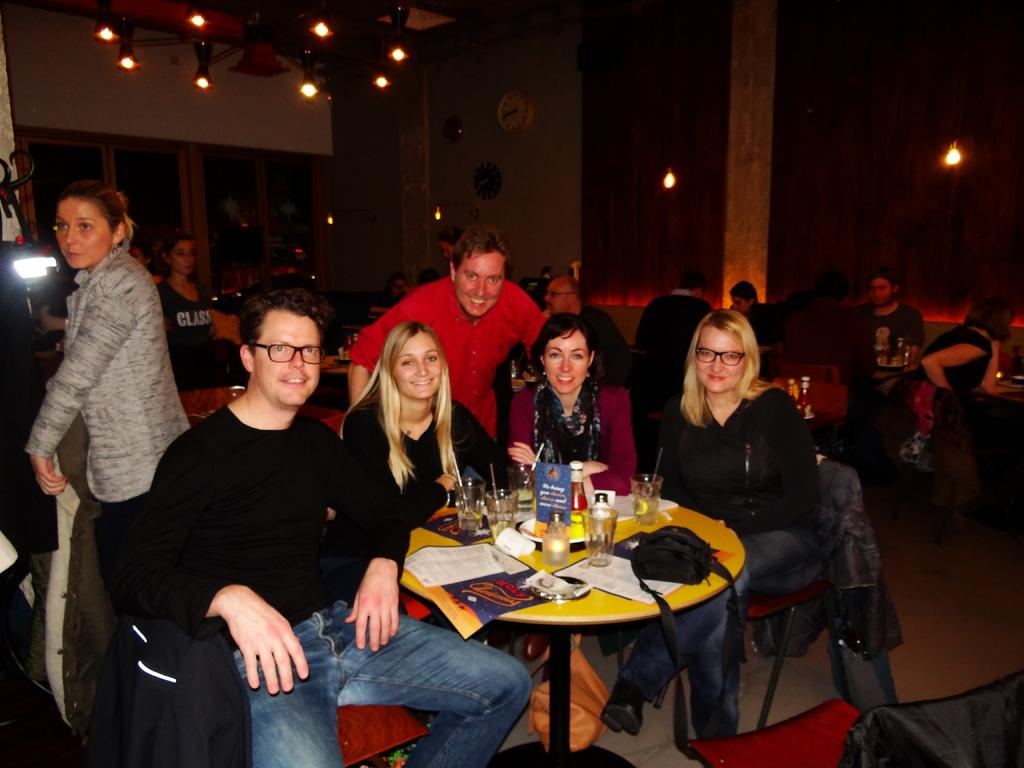Who is present in the image? There are people in the image. How are the people arranged in the image? The people are sitting in groups. Where are the people sitting in the image? The people are at tables. What type of location is depicted in the image? The setting is a restaurant. What type of view can be seen from the grandmother's perspective in the image? There is no grandmother present in the image, nor is there any indication of a specific viewpoint. 